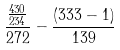<formula> <loc_0><loc_0><loc_500><loc_500>\frac { \frac { 4 3 0 } { 2 3 4 } } { 2 7 2 } - \frac { ( 3 3 3 - 1 ) } { 1 3 9 }</formula> 